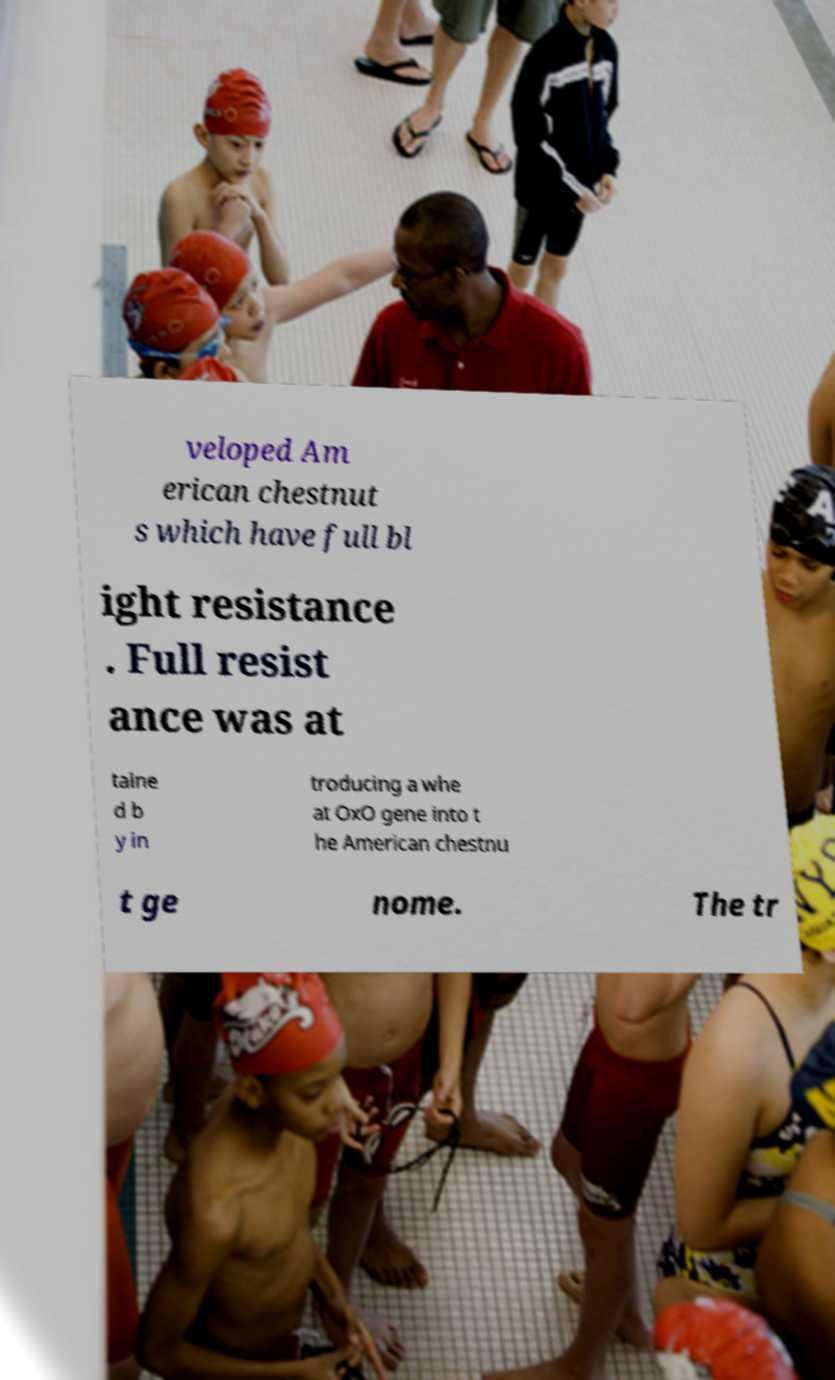Can you read and provide the text displayed in the image?This photo seems to have some interesting text. Can you extract and type it out for me? veloped Am erican chestnut s which have full bl ight resistance . Full resist ance was at taine d b y in troducing a whe at OxO gene into t he American chestnu t ge nome. The tr 